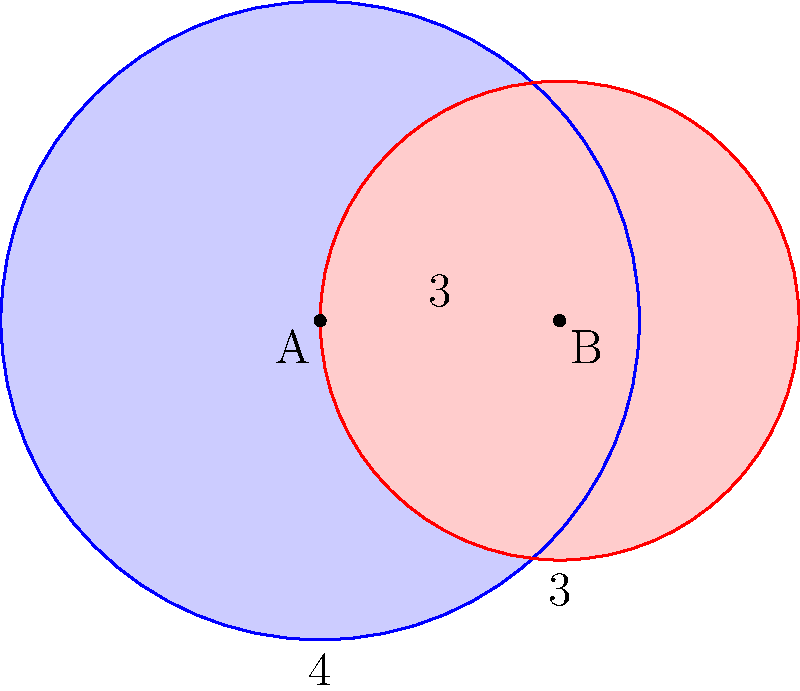For your surprise party, you've arranged two circular balloons to overlap. Balloon A has a radius of 4 units, and Balloon B has a radius of 3 units. The centers of the balloons are 3 units apart. What is the area of the overlapping region between the two balloons? (Use $\pi = 3.14$ for calculations) Let's solve this step-by-step:

1) First, we need to find the angle $\theta$ at the center of each circle formed by the radii to the intersection points.

2) For circle A: $\cos(\theta_A/2) = \frac{3}{2*4} = \frac{3}{8}$
   For circle B: $\cos(\theta_B/2) = \frac{3}{2*3} = \frac{1}{2}$

3) $\theta_A = 2 \arccos(\frac{3}{8}) \approx 2.0944$ radians
   $\theta_B = 2 \arccos(\frac{1}{2}) \approx 2.0944$ radians

4) The area of a sector is given by $\frac{1}{2}r^2\theta$

5) Area of sector A = $\frac{1}{2} * 4^2 * 2.0944 = 16.7552$
   Area of sector B = $\frac{1}{2} * 3^2 * 2.0944 = 9.4248$

6) The area of the triangle formed by the centers and an intersection point:
   $Area_{triangle} = \frac{1}{2} * 3 * 4 * \sin(\frac{\theta_A}{2}) = 2.5981$

7) The overlapping area is the sum of the two sectors minus twice the triangle area:
   $Area_{overlap} = 16.7552 + 9.4248 - 2(2.5981) = 20.9838$

8) Rounding to two decimal places: $20.98$ square units
Answer: $20.98$ square units 